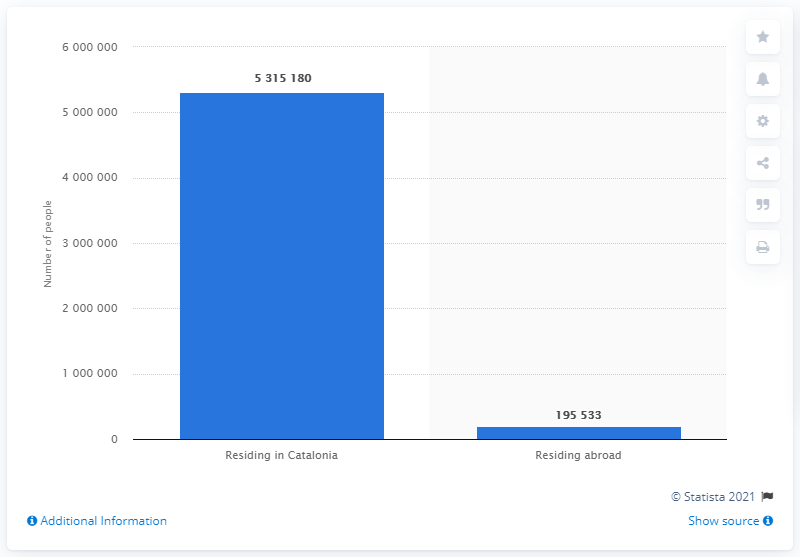Draw attention to some important aspects in this diagram. In 2015, a total of 195,533 voters in Catalonia resided abroad. 